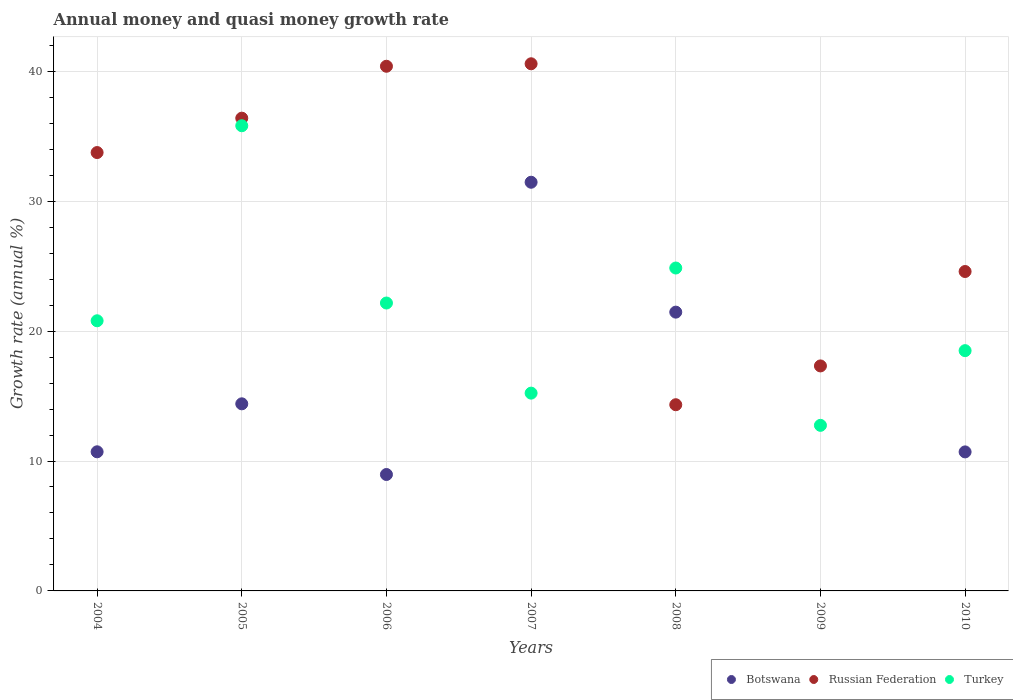How many different coloured dotlines are there?
Give a very brief answer. 3. Is the number of dotlines equal to the number of legend labels?
Offer a very short reply. No. What is the growth rate in Botswana in 2004?
Your answer should be very brief. 10.71. Across all years, what is the maximum growth rate in Russian Federation?
Your answer should be very brief. 40.58. Across all years, what is the minimum growth rate in Turkey?
Make the answer very short. 12.75. What is the total growth rate in Russian Federation in the graph?
Give a very brief answer. 207.35. What is the difference between the growth rate in Turkey in 2004 and that in 2007?
Your answer should be very brief. 5.57. What is the difference between the growth rate in Turkey in 2007 and the growth rate in Russian Federation in 2009?
Make the answer very short. -2.09. What is the average growth rate in Turkey per year?
Keep it short and to the point. 21.44. In the year 2006, what is the difference between the growth rate in Russian Federation and growth rate in Botswana?
Your answer should be compact. 31.43. In how many years, is the growth rate in Russian Federation greater than 36 %?
Keep it short and to the point. 3. What is the ratio of the growth rate in Russian Federation in 2006 to that in 2007?
Make the answer very short. 1. Is the difference between the growth rate in Russian Federation in 2008 and 2010 greater than the difference between the growth rate in Botswana in 2008 and 2010?
Provide a short and direct response. No. What is the difference between the highest and the second highest growth rate in Turkey?
Offer a terse response. 10.95. What is the difference between the highest and the lowest growth rate in Botswana?
Provide a short and direct response. 31.46. In how many years, is the growth rate in Russian Federation greater than the average growth rate in Russian Federation taken over all years?
Your answer should be very brief. 4. Is it the case that in every year, the sum of the growth rate in Botswana and growth rate in Russian Federation  is greater than the growth rate in Turkey?
Offer a terse response. Yes. Does the growth rate in Botswana monotonically increase over the years?
Your answer should be very brief. No. Is the growth rate in Russian Federation strictly greater than the growth rate in Turkey over the years?
Ensure brevity in your answer.  No. Is the growth rate in Russian Federation strictly less than the growth rate in Turkey over the years?
Keep it short and to the point. No. How many dotlines are there?
Give a very brief answer. 3. What is the difference between two consecutive major ticks on the Y-axis?
Ensure brevity in your answer.  10. Does the graph contain grids?
Give a very brief answer. Yes. Where does the legend appear in the graph?
Provide a succinct answer. Bottom right. How many legend labels are there?
Your answer should be compact. 3. What is the title of the graph?
Provide a short and direct response. Annual money and quasi money growth rate. What is the label or title of the X-axis?
Ensure brevity in your answer.  Years. What is the label or title of the Y-axis?
Ensure brevity in your answer.  Growth rate (annual %). What is the Growth rate (annual %) in Botswana in 2004?
Give a very brief answer. 10.71. What is the Growth rate (annual %) in Russian Federation in 2004?
Make the answer very short. 33.75. What is the Growth rate (annual %) in Turkey in 2004?
Your answer should be compact. 20.8. What is the Growth rate (annual %) of Botswana in 2005?
Your answer should be compact. 14.4. What is the Growth rate (annual %) of Russian Federation in 2005?
Give a very brief answer. 36.39. What is the Growth rate (annual %) of Turkey in 2005?
Ensure brevity in your answer.  35.81. What is the Growth rate (annual %) in Botswana in 2006?
Provide a short and direct response. 8.96. What is the Growth rate (annual %) of Russian Federation in 2006?
Your answer should be compact. 40.39. What is the Growth rate (annual %) of Turkey in 2006?
Your response must be concise. 22.16. What is the Growth rate (annual %) in Botswana in 2007?
Your answer should be very brief. 31.46. What is the Growth rate (annual %) of Russian Federation in 2007?
Your response must be concise. 40.58. What is the Growth rate (annual %) of Turkey in 2007?
Your answer should be very brief. 15.23. What is the Growth rate (annual %) of Botswana in 2008?
Your response must be concise. 21.46. What is the Growth rate (annual %) in Russian Federation in 2008?
Provide a short and direct response. 14.33. What is the Growth rate (annual %) in Turkey in 2008?
Provide a short and direct response. 24.86. What is the Growth rate (annual %) of Russian Federation in 2009?
Give a very brief answer. 17.32. What is the Growth rate (annual %) in Turkey in 2009?
Keep it short and to the point. 12.75. What is the Growth rate (annual %) of Botswana in 2010?
Your answer should be very brief. 10.7. What is the Growth rate (annual %) of Russian Federation in 2010?
Keep it short and to the point. 24.59. What is the Growth rate (annual %) in Turkey in 2010?
Keep it short and to the point. 18.5. Across all years, what is the maximum Growth rate (annual %) of Botswana?
Provide a short and direct response. 31.46. Across all years, what is the maximum Growth rate (annual %) of Russian Federation?
Offer a terse response. 40.58. Across all years, what is the maximum Growth rate (annual %) in Turkey?
Your answer should be compact. 35.81. Across all years, what is the minimum Growth rate (annual %) of Botswana?
Ensure brevity in your answer.  0. Across all years, what is the minimum Growth rate (annual %) in Russian Federation?
Your response must be concise. 14.33. Across all years, what is the minimum Growth rate (annual %) of Turkey?
Provide a short and direct response. 12.75. What is the total Growth rate (annual %) in Botswana in the graph?
Provide a short and direct response. 97.7. What is the total Growth rate (annual %) of Russian Federation in the graph?
Your answer should be very brief. 207.35. What is the total Growth rate (annual %) in Turkey in the graph?
Your answer should be very brief. 150.09. What is the difference between the Growth rate (annual %) in Botswana in 2004 and that in 2005?
Your response must be concise. -3.69. What is the difference between the Growth rate (annual %) in Russian Federation in 2004 and that in 2005?
Offer a very short reply. -2.65. What is the difference between the Growth rate (annual %) in Turkey in 2004 and that in 2005?
Your response must be concise. -15.01. What is the difference between the Growth rate (annual %) of Botswana in 2004 and that in 2006?
Make the answer very short. 1.75. What is the difference between the Growth rate (annual %) in Russian Federation in 2004 and that in 2006?
Provide a short and direct response. -6.64. What is the difference between the Growth rate (annual %) of Turkey in 2004 and that in 2006?
Your response must be concise. -1.37. What is the difference between the Growth rate (annual %) of Botswana in 2004 and that in 2007?
Give a very brief answer. -20.75. What is the difference between the Growth rate (annual %) of Russian Federation in 2004 and that in 2007?
Provide a short and direct response. -6.83. What is the difference between the Growth rate (annual %) of Turkey in 2004 and that in 2007?
Keep it short and to the point. 5.57. What is the difference between the Growth rate (annual %) of Botswana in 2004 and that in 2008?
Ensure brevity in your answer.  -10.75. What is the difference between the Growth rate (annual %) in Russian Federation in 2004 and that in 2008?
Provide a short and direct response. 19.41. What is the difference between the Growth rate (annual %) of Turkey in 2004 and that in 2008?
Your answer should be compact. -4.06. What is the difference between the Growth rate (annual %) in Russian Federation in 2004 and that in 2009?
Offer a terse response. 16.43. What is the difference between the Growth rate (annual %) in Turkey in 2004 and that in 2009?
Offer a terse response. 8.05. What is the difference between the Growth rate (annual %) in Botswana in 2004 and that in 2010?
Offer a terse response. 0.01. What is the difference between the Growth rate (annual %) of Russian Federation in 2004 and that in 2010?
Your answer should be very brief. 9.16. What is the difference between the Growth rate (annual %) of Turkey in 2004 and that in 2010?
Ensure brevity in your answer.  2.3. What is the difference between the Growth rate (annual %) in Botswana in 2005 and that in 2006?
Your answer should be compact. 5.44. What is the difference between the Growth rate (annual %) in Russian Federation in 2005 and that in 2006?
Keep it short and to the point. -4. What is the difference between the Growth rate (annual %) of Turkey in 2005 and that in 2006?
Offer a very short reply. 13.65. What is the difference between the Growth rate (annual %) of Botswana in 2005 and that in 2007?
Your answer should be very brief. -17.06. What is the difference between the Growth rate (annual %) of Russian Federation in 2005 and that in 2007?
Your answer should be compact. -4.19. What is the difference between the Growth rate (annual %) in Turkey in 2005 and that in 2007?
Your answer should be compact. 20.58. What is the difference between the Growth rate (annual %) in Botswana in 2005 and that in 2008?
Offer a terse response. -7.06. What is the difference between the Growth rate (annual %) of Russian Federation in 2005 and that in 2008?
Your answer should be compact. 22.06. What is the difference between the Growth rate (annual %) of Turkey in 2005 and that in 2008?
Offer a very short reply. 10.95. What is the difference between the Growth rate (annual %) in Russian Federation in 2005 and that in 2009?
Provide a short and direct response. 19.07. What is the difference between the Growth rate (annual %) in Turkey in 2005 and that in 2009?
Your answer should be very brief. 23.06. What is the difference between the Growth rate (annual %) in Botswana in 2005 and that in 2010?
Give a very brief answer. 3.7. What is the difference between the Growth rate (annual %) of Russian Federation in 2005 and that in 2010?
Make the answer very short. 11.8. What is the difference between the Growth rate (annual %) in Turkey in 2005 and that in 2010?
Ensure brevity in your answer.  17.31. What is the difference between the Growth rate (annual %) of Botswana in 2006 and that in 2007?
Keep it short and to the point. -22.5. What is the difference between the Growth rate (annual %) of Russian Federation in 2006 and that in 2007?
Keep it short and to the point. -0.19. What is the difference between the Growth rate (annual %) of Turkey in 2006 and that in 2007?
Your response must be concise. 6.94. What is the difference between the Growth rate (annual %) of Botswana in 2006 and that in 2008?
Offer a very short reply. -12.5. What is the difference between the Growth rate (annual %) in Russian Federation in 2006 and that in 2008?
Provide a succinct answer. 26.06. What is the difference between the Growth rate (annual %) of Turkey in 2006 and that in 2008?
Give a very brief answer. -2.69. What is the difference between the Growth rate (annual %) in Russian Federation in 2006 and that in 2009?
Offer a terse response. 23.07. What is the difference between the Growth rate (annual %) in Turkey in 2006 and that in 2009?
Your answer should be very brief. 9.42. What is the difference between the Growth rate (annual %) of Botswana in 2006 and that in 2010?
Make the answer very short. -1.74. What is the difference between the Growth rate (annual %) in Russian Federation in 2006 and that in 2010?
Your answer should be compact. 15.8. What is the difference between the Growth rate (annual %) of Turkey in 2006 and that in 2010?
Your response must be concise. 3.67. What is the difference between the Growth rate (annual %) of Botswana in 2007 and that in 2008?
Your response must be concise. 10. What is the difference between the Growth rate (annual %) in Russian Federation in 2007 and that in 2008?
Your response must be concise. 26.25. What is the difference between the Growth rate (annual %) of Turkey in 2007 and that in 2008?
Offer a very short reply. -9.63. What is the difference between the Growth rate (annual %) in Russian Federation in 2007 and that in 2009?
Offer a terse response. 23.26. What is the difference between the Growth rate (annual %) of Turkey in 2007 and that in 2009?
Make the answer very short. 2.48. What is the difference between the Growth rate (annual %) of Botswana in 2007 and that in 2010?
Provide a short and direct response. 20.76. What is the difference between the Growth rate (annual %) in Russian Federation in 2007 and that in 2010?
Provide a short and direct response. 15.99. What is the difference between the Growth rate (annual %) in Turkey in 2007 and that in 2010?
Provide a short and direct response. -3.27. What is the difference between the Growth rate (annual %) in Russian Federation in 2008 and that in 2009?
Keep it short and to the point. -2.99. What is the difference between the Growth rate (annual %) of Turkey in 2008 and that in 2009?
Keep it short and to the point. 12.11. What is the difference between the Growth rate (annual %) in Botswana in 2008 and that in 2010?
Offer a terse response. 10.76. What is the difference between the Growth rate (annual %) in Russian Federation in 2008 and that in 2010?
Offer a terse response. -10.26. What is the difference between the Growth rate (annual %) in Turkey in 2008 and that in 2010?
Provide a succinct answer. 6.36. What is the difference between the Growth rate (annual %) in Russian Federation in 2009 and that in 2010?
Give a very brief answer. -7.27. What is the difference between the Growth rate (annual %) in Turkey in 2009 and that in 2010?
Give a very brief answer. -5.75. What is the difference between the Growth rate (annual %) of Botswana in 2004 and the Growth rate (annual %) of Russian Federation in 2005?
Provide a succinct answer. -25.68. What is the difference between the Growth rate (annual %) of Botswana in 2004 and the Growth rate (annual %) of Turkey in 2005?
Offer a terse response. -25.1. What is the difference between the Growth rate (annual %) in Russian Federation in 2004 and the Growth rate (annual %) in Turkey in 2005?
Keep it short and to the point. -2.06. What is the difference between the Growth rate (annual %) in Botswana in 2004 and the Growth rate (annual %) in Russian Federation in 2006?
Ensure brevity in your answer.  -29.68. What is the difference between the Growth rate (annual %) in Botswana in 2004 and the Growth rate (annual %) in Turkey in 2006?
Provide a short and direct response. -11.45. What is the difference between the Growth rate (annual %) in Russian Federation in 2004 and the Growth rate (annual %) in Turkey in 2006?
Keep it short and to the point. 11.58. What is the difference between the Growth rate (annual %) of Botswana in 2004 and the Growth rate (annual %) of Russian Federation in 2007?
Ensure brevity in your answer.  -29.87. What is the difference between the Growth rate (annual %) in Botswana in 2004 and the Growth rate (annual %) in Turkey in 2007?
Give a very brief answer. -4.52. What is the difference between the Growth rate (annual %) of Russian Federation in 2004 and the Growth rate (annual %) of Turkey in 2007?
Your answer should be compact. 18.52. What is the difference between the Growth rate (annual %) of Botswana in 2004 and the Growth rate (annual %) of Russian Federation in 2008?
Provide a succinct answer. -3.62. What is the difference between the Growth rate (annual %) in Botswana in 2004 and the Growth rate (annual %) in Turkey in 2008?
Ensure brevity in your answer.  -14.15. What is the difference between the Growth rate (annual %) in Russian Federation in 2004 and the Growth rate (annual %) in Turkey in 2008?
Offer a very short reply. 8.89. What is the difference between the Growth rate (annual %) of Botswana in 2004 and the Growth rate (annual %) of Russian Federation in 2009?
Your answer should be very brief. -6.61. What is the difference between the Growth rate (annual %) of Botswana in 2004 and the Growth rate (annual %) of Turkey in 2009?
Ensure brevity in your answer.  -2.04. What is the difference between the Growth rate (annual %) of Russian Federation in 2004 and the Growth rate (annual %) of Turkey in 2009?
Provide a short and direct response. 21. What is the difference between the Growth rate (annual %) in Botswana in 2004 and the Growth rate (annual %) in Russian Federation in 2010?
Offer a terse response. -13.88. What is the difference between the Growth rate (annual %) of Botswana in 2004 and the Growth rate (annual %) of Turkey in 2010?
Offer a very short reply. -7.79. What is the difference between the Growth rate (annual %) in Russian Federation in 2004 and the Growth rate (annual %) in Turkey in 2010?
Provide a succinct answer. 15.25. What is the difference between the Growth rate (annual %) in Botswana in 2005 and the Growth rate (annual %) in Russian Federation in 2006?
Provide a short and direct response. -25.99. What is the difference between the Growth rate (annual %) of Botswana in 2005 and the Growth rate (annual %) of Turkey in 2006?
Provide a short and direct response. -7.76. What is the difference between the Growth rate (annual %) in Russian Federation in 2005 and the Growth rate (annual %) in Turkey in 2006?
Your answer should be compact. 14.23. What is the difference between the Growth rate (annual %) of Botswana in 2005 and the Growth rate (annual %) of Russian Federation in 2007?
Offer a very short reply. -26.18. What is the difference between the Growth rate (annual %) in Botswana in 2005 and the Growth rate (annual %) in Turkey in 2007?
Offer a terse response. -0.82. What is the difference between the Growth rate (annual %) in Russian Federation in 2005 and the Growth rate (annual %) in Turkey in 2007?
Make the answer very short. 21.17. What is the difference between the Growth rate (annual %) of Botswana in 2005 and the Growth rate (annual %) of Russian Federation in 2008?
Give a very brief answer. 0.07. What is the difference between the Growth rate (annual %) of Botswana in 2005 and the Growth rate (annual %) of Turkey in 2008?
Provide a succinct answer. -10.45. What is the difference between the Growth rate (annual %) in Russian Federation in 2005 and the Growth rate (annual %) in Turkey in 2008?
Offer a terse response. 11.54. What is the difference between the Growth rate (annual %) in Botswana in 2005 and the Growth rate (annual %) in Russian Federation in 2009?
Provide a succinct answer. -2.92. What is the difference between the Growth rate (annual %) in Botswana in 2005 and the Growth rate (annual %) in Turkey in 2009?
Ensure brevity in your answer.  1.66. What is the difference between the Growth rate (annual %) of Russian Federation in 2005 and the Growth rate (annual %) of Turkey in 2009?
Provide a short and direct response. 23.65. What is the difference between the Growth rate (annual %) of Botswana in 2005 and the Growth rate (annual %) of Russian Federation in 2010?
Make the answer very short. -10.19. What is the difference between the Growth rate (annual %) of Botswana in 2005 and the Growth rate (annual %) of Turkey in 2010?
Your answer should be compact. -4.09. What is the difference between the Growth rate (annual %) in Russian Federation in 2005 and the Growth rate (annual %) in Turkey in 2010?
Your answer should be compact. 17.9. What is the difference between the Growth rate (annual %) of Botswana in 2006 and the Growth rate (annual %) of Russian Federation in 2007?
Ensure brevity in your answer.  -31.62. What is the difference between the Growth rate (annual %) in Botswana in 2006 and the Growth rate (annual %) in Turkey in 2007?
Your answer should be very brief. -6.26. What is the difference between the Growth rate (annual %) of Russian Federation in 2006 and the Growth rate (annual %) of Turkey in 2007?
Make the answer very short. 25.16. What is the difference between the Growth rate (annual %) of Botswana in 2006 and the Growth rate (annual %) of Russian Federation in 2008?
Keep it short and to the point. -5.37. What is the difference between the Growth rate (annual %) of Botswana in 2006 and the Growth rate (annual %) of Turkey in 2008?
Provide a short and direct response. -15.9. What is the difference between the Growth rate (annual %) of Russian Federation in 2006 and the Growth rate (annual %) of Turkey in 2008?
Provide a short and direct response. 15.53. What is the difference between the Growth rate (annual %) of Botswana in 2006 and the Growth rate (annual %) of Russian Federation in 2009?
Your answer should be very brief. -8.36. What is the difference between the Growth rate (annual %) in Botswana in 2006 and the Growth rate (annual %) in Turkey in 2009?
Give a very brief answer. -3.78. What is the difference between the Growth rate (annual %) of Russian Federation in 2006 and the Growth rate (annual %) of Turkey in 2009?
Keep it short and to the point. 27.64. What is the difference between the Growth rate (annual %) in Botswana in 2006 and the Growth rate (annual %) in Russian Federation in 2010?
Make the answer very short. -15.63. What is the difference between the Growth rate (annual %) of Botswana in 2006 and the Growth rate (annual %) of Turkey in 2010?
Provide a succinct answer. -9.53. What is the difference between the Growth rate (annual %) of Russian Federation in 2006 and the Growth rate (annual %) of Turkey in 2010?
Offer a very short reply. 21.89. What is the difference between the Growth rate (annual %) of Botswana in 2007 and the Growth rate (annual %) of Russian Federation in 2008?
Give a very brief answer. 17.13. What is the difference between the Growth rate (annual %) in Botswana in 2007 and the Growth rate (annual %) in Turkey in 2008?
Provide a succinct answer. 6.6. What is the difference between the Growth rate (annual %) of Russian Federation in 2007 and the Growth rate (annual %) of Turkey in 2008?
Offer a terse response. 15.72. What is the difference between the Growth rate (annual %) of Botswana in 2007 and the Growth rate (annual %) of Russian Federation in 2009?
Offer a terse response. 14.14. What is the difference between the Growth rate (annual %) in Botswana in 2007 and the Growth rate (annual %) in Turkey in 2009?
Give a very brief answer. 18.71. What is the difference between the Growth rate (annual %) in Russian Federation in 2007 and the Growth rate (annual %) in Turkey in 2009?
Ensure brevity in your answer.  27.83. What is the difference between the Growth rate (annual %) of Botswana in 2007 and the Growth rate (annual %) of Russian Federation in 2010?
Your answer should be very brief. 6.87. What is the difference between the Growth rate (annual %) in Botswana in 2007 and the Growth rate (annual %) in Turkey in 2010?
Provide a succinct answer. 12.96. What is the difference between the Growth rate (annual %) of Russian Federation in 2007 and the Growth rate (annual %) of Turkey in 2010?
Your answer should be compact. 22.08. What is the difference between the Growth rate (annual %) of Botswana in 2008 and the Growth rate (annual %) of Russian Federation in 2009?
Make the answer very short. 4.14. What is the difference between the Growth rate (annual %) in Botswana in 2008 and the Growth rate (annual %) in Turkey in 2009?
Give a very brief answer. 8.71. What is the difference between the Growth rate (annual %) in Russian Federation in 2008 and the Growth rate (annual %) in Turkey in 2009?
Make the answer very short. 1.59. What is the difference between the Growth rate (annual %) of Botswana in 2008 and the Growth rate (annual %) of Russian Federation in 2010?
Your response must be concise. -3.13. What is the difference between the Growth rate (annual %) in Botswana in 2008 and the Growth rate (annual %) in Turkey in 2010?
Offer a very short reply. 2.96. What is the difference between the Growth rate (annual %) in Russian Federation in 2008 and the Growth rate (annual %) in Turkey in 2010?
Give a very brief answer. -4.16. What is the difference between the Growth rate (annual %) in Russian Federation in 2009 and the Growth rate (annual %) in Turkey in 2010?
Your response must be concise. -1.18. What is the average Growth rate (annual %) in Botswana per year?
Keep it short and to the point. 13.96. What is the average Growth rate (annual %) in Russian Federation per year?
Provide a short and direct response. 29.62. What is the average Growth rate (annual %) in Turkey per year?
Your answer should be compact. 21.44. In the year 2004, what is the difference between the Growth rate (annual %) in Botswana and Growth rate (annual %) in Russian Federation?
Provide a succinct answer. -23.04. In the year 2004, what is the difference between the Growth rate (annual %) in Botswana and Growth rate (annual %) in Turkey?
Your answer should be very brief. -10.09. In the year 2004, what is the difference between the Growth rate (annual %) in Russian Federation and Growth rate (annual %) in Turkey?
Your answer should be compact. 12.95. In the year 2005, what is the difference between the Growth rate (annual %) of Botswana and Growth rate (annual %) of Russian Federation?
Give a very brief answer. -21.99. In the year 2005, what is the difference between the Growth rate (annual %) of Botswana and Growth rate (annual %) of Turkey?
Offer a terse response. -21.41. In the year 2005, what is the difference between the Growth rate (annual %) in Russian Federation and Growth rate (annual %) in Turkey?
Ensure brevity in your answer.  0.58. In the year 2006, what is the difference between the Growth rate (annual %) of Botswana and Growth rate (annual %) of Russian Federation?
Make the answer very short. -31.43. In the year 2006, what is the difference between the Growth rate (annual %) in Botswana and Growth rate (annual %) in Turkey?
Your answer should be compact. -13.2. In the year 2006, what is the difference between the Growth rate (annual %) of Russian Federation and Growth rate (annual %) of Turkey?
Your answer should be compact. 18.23. In the year 2007, what is the difference between the Growth rate (annual %) in Botswana and Growth rate (annual %) in Russian Federation?
Offer a very short reply. -9.12. In the year 2007, what is the difference between the Growth rate (annual %) of Botswana and Growth rate (annual %) of Turkey?
Keep it short and to the point. 16.23. In the year 2007, what is the difference between the Growth rate (annual %) in Russian Federation and Growth rate (annual %) in Turkey?
Offer a terse response. 25.35. In the year 2008, what is the difference between the Growth rate (annual %) in Botswana and Growth rate (annual %) in Russian Federation?
Provide a short and direct response. 7.13. In the year 2008, what is the difference between the Growth rate (annual %) of Botswana and Growth rate (annual %) of Turkey?
Provide a short and direct response. -3.4. In the year 2008, what is the difference between the Growth rate (annual %) in Russian Federation and Growth rate (annual %) in Turkey?
Provide a short and direct response. -10.52. In the year 2009, what is the difference between the Growth rate (annual %) of Russian Federation and Growth rate (annual %) of Turkey?
Ensure brevity in your answer.  4.57. In the year 2010, what is the difference between the Growth rate (annual %) of Botswana and Growth rate (annual %) of Russian Federation?
Give a very brief answer. -13.89. In the year 2010, what is the difference between the Growth rate (annual %) of Botswana and Growth rate (annual %) of Turkey?
Keep it short and to the point. -7.79. In the year 2010, what is the difference between the Growth rate (annual %) in Russian Federation and Growth rate (annual %) in Turkey?
Provide a short and direct response. 6.09. What is the ratio of the Growth rate (annual %) in Botswana in 2004 to that in 2005?
Provide a short and direct response. 0.74. What is the ratio of the Growth rate (annual %) in Russian Federation in 2004 to that in 2005?
Your answer should be compact. 0.93. What is the ratio of the Growth rate (annual %) in Turkey in 2004 to that in 2005?
Offer a very short reply. 0.58. What is the ratio of the Growth rate (annual %) in Botswana in 2004 to that in 2006?
Your answer should be very brief. 1.2. What is the ratio of the Growth rate (annual %) in Russian Federation in 2004 to that in 2006?
Give a very brief answer. 0.84. What is the ratio of the Growth rate (annual %) of Turkey in 2004 to that in 2006?
Offer a terse response. 0.94. What is the ratio of the Growth rate (annual %) in Botswana in 2004 to that in 2007?
Keep it short and to the point. 0.34. What is the ratio of the Growth rate (annual %) of Russian Federation in 2004 to that in 2007?
Your answer should be very brief. 0.83. What is the ratio of the Growth rate (annual %) of Turkey in 2004 to that in 2007?
Keep it short and to the point. 1.37. What is the ratio of the Growth rate (annual %) in Botswana in 2004 to that in 2008?
Give a very brief answer. 0.5. What is the ratio of the Growth rate (annual %) in Russian Federation in 2004 to that in 2008?
Ensure brevity in your answer.  2.35. What is the ratio of the Growth rate (annual %) in Turkey in 2004 to that in 2008?
Provide a succinct answer. 0.84. What is the ratio of the Growth rate (annual %) in Russian Federation in 2004 to that in 2009?
Your response must be concise. 1.95. What is the ratio of the Growth rate (annual %) in Turkey in 2004 to that in 2009?
Make the answer very short. 1.63. What is the ratio of the Growth rate (annual %) of Botswana in 2004 to that in 2010?
Keep it short and to the point. 1. What is the ratio of the Growth rate (annual %) in Russian Federation in 2004 to that in 2010?
Your answer should be compact. 1.37. What is the ratio of the Growth rate (annual %) in Turkey in 2004 to that in 2010?
Provide a short and direct response. 1.12. What is the ratio of the Growth rate (annual %) of Botswana in 2005 to that in 2006?
Your response must be concise. 1.61. What is the ratio of the Growth rate (annual %) in Russian Federation in 2005 to that in 2006?
Offer a terse response. 0.9. What is the ratio of the Growth rate (annual %) of Turkey in 2005 to that in 2006?
Make the answer very short. 1.62. What is the ratio of the Growth rate (annual %) in Botswana in 2005 to that in 2007?
Provide a succinct answer. 0.46. What is the ratio of the Growth rate (annual %) of Russian Federation in 2005 to that in 2007?
Provide a succinct answer. 0.9. What is the ratio of the Growth rate (annual %) of Turkey in 2005 to that in 2007?
Your response must be concise. 2.35. What is the ratio of the Growth rate (annual %) of Botswana in 2005 to that in 2008?
Your answer should be very brief. 0.67. What is the ratio of the Growth rate (annual %) in Russian Federation in 2005 to that in 2008?
Provide a short and direct response. 2.54. What is the ratio of the Growth rate (annual %) of Turkey in 2005 to that in 2008?
Your response must be concise. 1.44. What is the ratio of the Growth rate (annual %) of Russian Federation in 2005 to that in 2009?
Your response must be concise. 2.1. What is the ratio of the Growth rate (annual %) in Turkey in 2005 to that in 2009?
Ensure brevity in your answer.  2.81. What is the ratio of the Growth rate (annual %) in Botswana in 2005 to that in 2010?
Give a very brief answer. 1.35. What is the ratio of the Growth rate (annual %) of Russian Federation in 2005 to that in 2010?
Your response must be concise. 1.48. What is the ratio of the Growth rate (annual %) in Turkey in 2005 to that in 2010?
Offer a terse response. 1.94. What is the ratio of the Growth rate (annual %) in Botswana in 2006 to that in 2007?
Keep it short and to the point. 0.28. What is the ratio of the Growth rate (annual %) of Turkey in 2006 to that in 2007?
Keep it short and to the point. 1.46. What is the ratio of the Growth rate (annual %) of Botswana in 2006 to that in 2008?
Your response must be concise. 0.42. What is the ratio of the Growth rate (annual %) in Russian Federation in 2006 to that in 2008?
Give a very brief answer. 2.82. What is the ratio of the Growth rate (annual %) in Turkey in 2006 to that in 2008?
Your response must be concise. 0.89. What is the ratio of the Growth rate (annual %) of Russian Federation in 2006 to that in 2009?
Offer a very short reply. 2.33. What is the ratio of the Growth rate (annual %) of Turkey in 2006 to that in 2009?
Give a very brief answer. 1.74. What is the ratio of the Growth rate (annual %) in Botswana in 2006 to that in 2010?
Offer a very short reply. 0.84. What is the ratio of the Growth rate (annual %) of Russian Federation in 2006 to that in 2010?
Provide a succinct answer. 1.64. What is the ratio of the Growth rate (annual %) of Turkey in 2006 to that in 2010?
Your response must be concise. 1.2. What is the ratio of the Growth rate (annual %) of Botswana in 2007 to that in 2008?
Offer a terse response. 1.47. What is the ratio of the Growth rate (annual %) of Russian Federation in 2007 to that in 2008?
Your answer should be very brief. 2.83. What is the ratio of the Growth rate (annual %) of Turkey in 2007 to that in 2008?
Give a very brief answer. 0.61. What is the ratio of the Growth rate (annual %) in Russian Federation in 2007 to that in 2009?
Keep it short and to the point. 2.34. What is the ratio of the Growth rate (annual %) of Turkey in 2007 to that in 2009?
Provide a short and direct response. 1.19. What is the ratio of the Growth rate (annual %) in Botswana in 2007 to that in 2010?
Offer a terse response. 2.94. What is the ratio of the Growth rate (annual %) in Russian Federation in 2007 to that in 2010?
Offer a very short reply. 1.65. What is the ratio of the Growth rate (annual %) of Turkey in 2007 to that in 2010?
Keep it short and to the point. 0.82. What is the ratio of the Growth rate (annual %) of Russian Federation in 2008 to that in 2009?
Make the answer very short. 0.83. What is the ratio of the Growth rate (annual %) of Turkey in 2008 to that in 2009?
Your answer should be very brief. 1.95. What is the ratio of the Growth rate (annual %) in Botswana in 2008 to that in 2010?
Ensure brevity in your answer.  2.01. What is the ratio of the Growth rate (annual %) in Russian Federation in 2008 to that in 2010?
Offer a very short reply. 0.58. What is the ratio of the Growth rate (annual %) of Turkey in 2008 to that in 2010?
Make the answer very short. 1.34. What is the ratio of the Growth rate (annual %) in Russian Federation in 2009 to that in 2010?
Provide a succinct answer. 0.7. What is the ratio of the Growth rate (annual %) of Turkey in 2009 to that in 2010?
Your answer should be compact. 0.69. What is the difference between the highest and the second highest Growth rate (annual %) in Botswana?
Ensure brevity in your answer.  10. What is the difference between the highest and the second highest Growth rate (annual %) of Russian Federation?
Give a very brief answer. 0.19. What is the difference between the highest and the second highest Growth rate (annual %) in Turkey?
Offer a very short reply. 10.95. What is the difference between the highest and the lowest Growth rate (annual %) of Botswana?
Your response must be concise. 31.46. What is the difference between the highest and the lowest Growth rate (annual %) of Russian Federation?
Keep it short and to the point. 26.25. What is the difference between the highest and the lowest Growth rate (annual %) in Turkey?
Give a very brief answer. 23.06. 